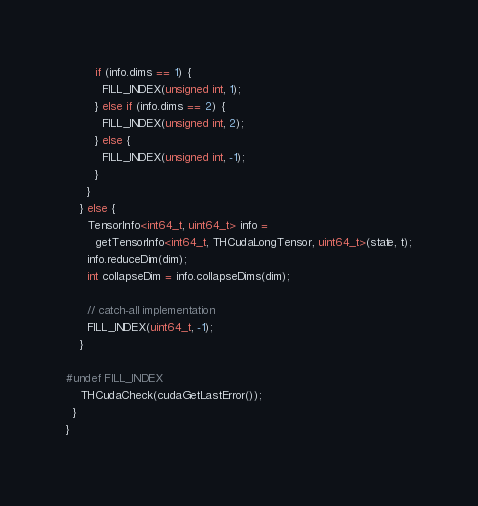Convert code to text. <code><loc_0><loc_0><loc_500><loc_500><_Cuda_>        if (info.dims == 1) {
          FILL_INDEX(unsigned int, 1);
        } else if (info.dims == 2) {
          FILL_INDEX(unsigned int, 2);
        } else {
          FILL_INDEX(unsigned int, -1);
        }
      }
    } else {
      TensorInfo<int64_t, uint64_t> info =
        getTensorInfo<int64_t, THCudaLongTensor, uint64_t>(state, t);
      info.reduceDim(dim);
      int collapseDim = info.collapseDims(dim);

      // catch-all implementation
      FILL_INDEX(uint64_t, -1);
    }

#undef FILL_INDEX
    THCudaCheck(cudaGetLastError());
  }
}
</code> 